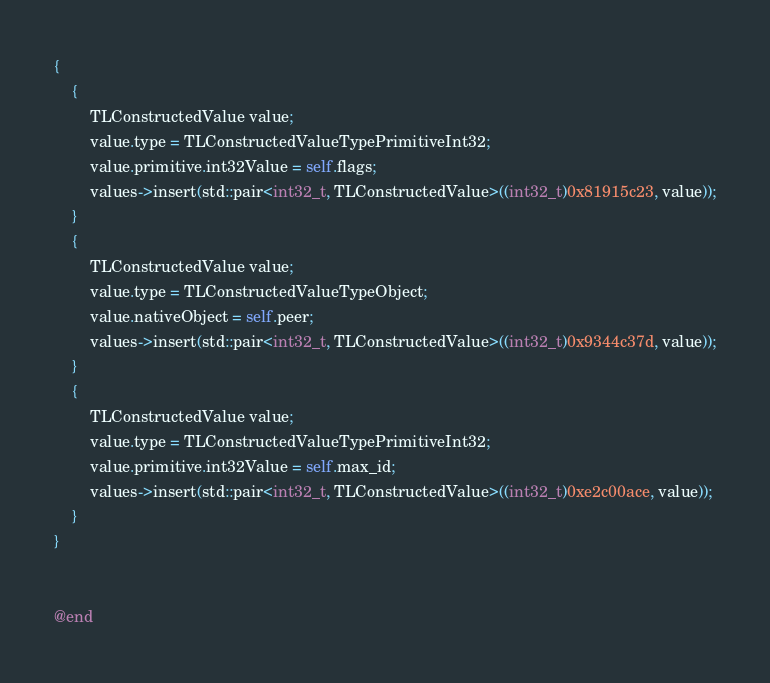Convert code to text. <code><loc_0><loc_0><loc_500><loc_500><_ObjectiveC_>{
    {
        TLConstructedValue value;
        value.type = TLConstructedValueTypePrimitiveInt32;
        value.primitive.int32Value = self.flags;
        values->insert(std::pair<int32_t, TLConstructedValue>((int32_t)0x81915c23, value));
    }
    {
        TLConstructedValue value;
        value.type = TLConstructedValueTypeObject;
        value.nativeObject = self.peer;
        values->insert(std::pair<int32_t, TLConstructedValue>((int32_t)0x9344c37d, value));
    }
    {
        TLConstructedValue value;
        value.type = TLConstructedValueTypePrimitiveInt32;
        value.primitive.int32Value = self.max_id;
        values->insert(std::pair<int32_t, TLConstructedValue>((int32_t)0xe2c00ace, value));
    }
}


@end

</code> 